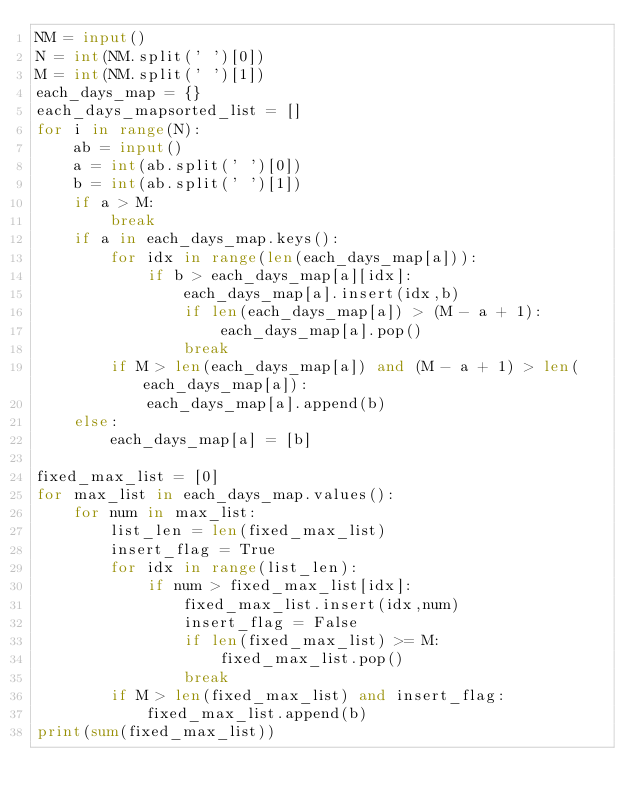<code> <loc_0><loc_0><loc_500><loc_500><_Python_>NM = input()
N = int(NM.split(' ')[0])
M = int(NM.split(' ')[1])
each_days_map = {}
each_days_mapsorted_list = []
for i in range(N):
    ab = input()
    a = int(ab.split(' ')[0])
    b = int(ab.split(' ')[1])
    if a > M:
        break 
    if a in each_days_map.keys():
        for idx in range(len(each_days_map[a])):
            if b > each_days_map[a][idx]:
                each_days_map[a].insert(idx,b)
                if len(each_days_map[a]) > (M - a + 1):
                    each_days_map[a].pop()
                break
        if M > len(each_days_map[a]) and (M - a + 1) > len(each_days_map[a]):
            each_days_map[a].append(b)
    else:
        each_days_map[a] = [b]

fixed_max_list = [0]
for max_list in each_days_map.values():
    for num in max_list:
        list_len = len(fixed_max_list)
        insert_flag = True
        for idx in range(list_len):
            if num > fixed_max_list[idx]:
                fixed_max_list.insert(idx,num)
                insert_flag = False
                if len(fixed_max_list) >= M:
                    fixed_max_list.pop()
                break
        if M > len(fixed_max_list) and insert_flag:
            fixed_max_list.append(b)
print(sum(fixed_max_list))</code> 